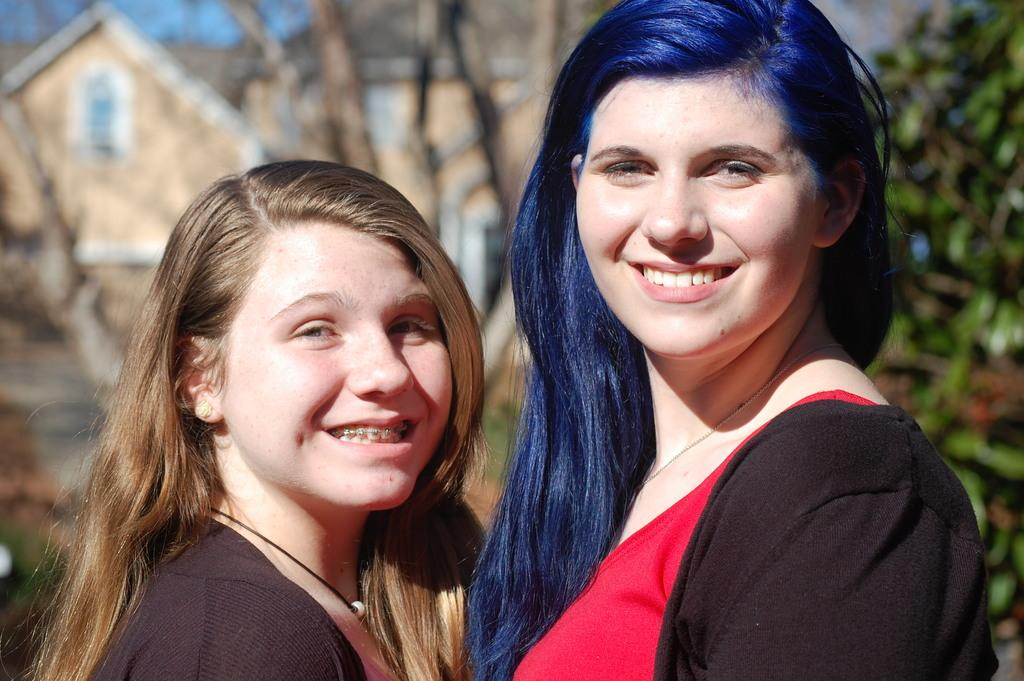How many people are in the image? There are two women in the image. What is the facial expression of the women? The women are smiling. What can be seen in the background of the image? There are buildings and trees in the background of the image. How would you describe the background in the image? The background appears blurry. What type of plant is being used to write the message on the ink bottle in the image? There is no plant or ink bottle present in the image. What flavor of soda is the woman holding in the image? There is no soda present in the image. 